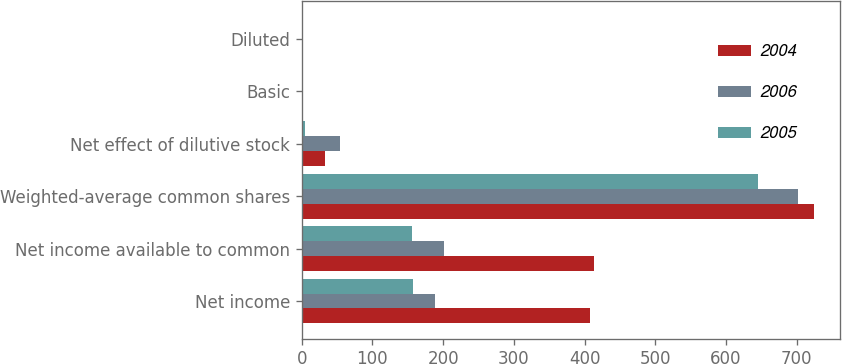Convert chart. <chart><loc_0><loc_0><loc_500><loc_500><stacked_bar_chart><ecel><fcel>Net income<fcel>Net income available to common<fcel>Weighted-average common shares<fcel>Net effect of dilutive stock<fcel>Basic<fcel>Diluted<nl><fcel>2004<fcel>408<fcel>414<fcel>725<fcel>33<fcel>0.59<fcel>0.57<nl><fcel>2006<fcel>188<fcel>202<fcel>702<fcel>54<fcel>0.29<fcel>0.29<nl><fcel>2005<fcel>157<fcel>156<fcel>646<fcel>5<fcel>0.24<fcel>0.24<nl></chart> 